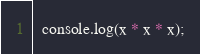<code> <loc_0><loc_0><loc_500><loc_500><_JavaScript_>
  console.log(x * x * x);</code> 